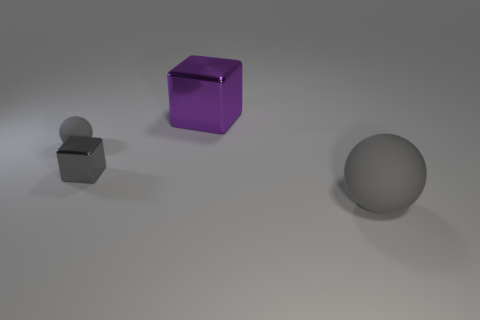Could you guess the material these objects are made of? While it's not possible to ascertain the exact materials from an image alone, the reflective nature and smooth surfaces suggest the objects might be made of metal or a kind of reflective plastic or glass. However, the perception of material can also depend on the lighting and rendering if computer-generated. 